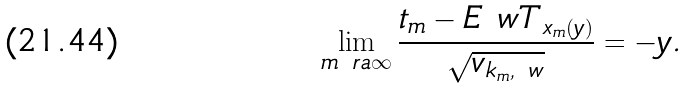Convert formula to latex. <formula><loc_0><loc_0><loc_500><loc_500>\lim _ { m \ r a \infty } \frac { t _ { m } - E _ { \ } w T _ { x _ { m } ( y ) } } { \sqrt { v _ { k _ { m } , \ w } } } = - y .</formula> 